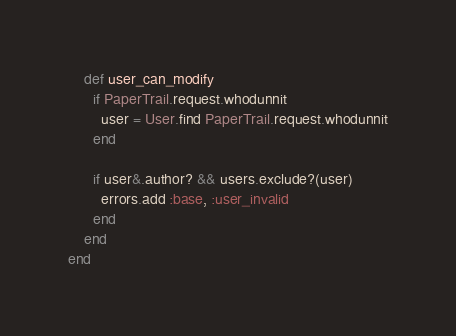<code> <loc_0><loc_0><loc_500><loc_500><_Ruby_>    def user_can_modify
      if PaperTrail.request.whodunnit
        user = User.find PaperTrail.request.whodunnit
      end

      if user&.author? && users.exclude?(user)
        errors.add :base, :user_invalid
      end
    end
end
</code> 